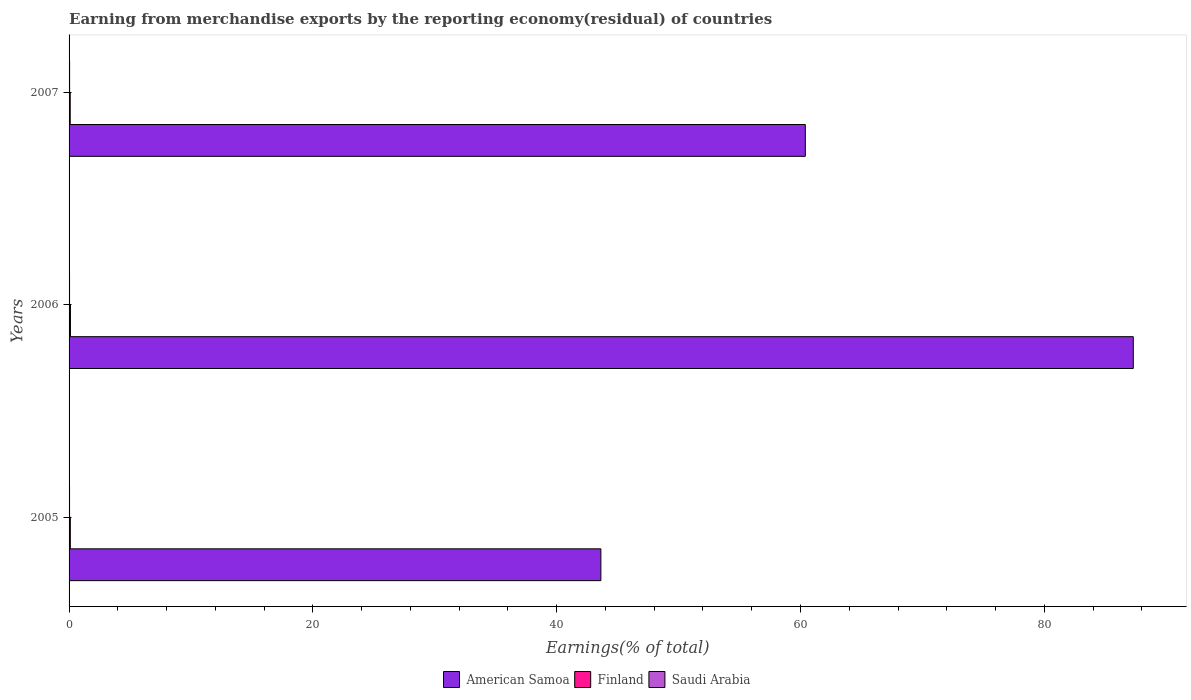Are the number of bars per tick equal to the number of legend labels?
Offer a terse response. Yes. Are the number of bars on each tick of the Y-axis equal?
Your response must be concise. Yes. How many bars are there on the 3rd tick from the top?
Your response must be concise. 3. How many bars are there on the 1st tick from the bottom?
Keep it short and to the point. 3. What is the label of the 3rd group of bars from the top?
Your answer should be compact. 2005. What is the percentage of amount earned from merchandise exports in Finland in 2007?
Make the answer very short. 0.09. Across all years, what is the maximum percentage of amount earned from merchandise exports in Saudi Arabia?
Offer a very short reply. 0.04. Across all years, what is the minimum percentage of amount earned from merchandise exports in Saudi Arabia?
Keep it short and to the point. 0.04. In which year was the percentage of amount earned from merchandise exports in American Samoa minimum?
Keep it short and to the point. 2005. What is the total percentage of amount earned from merchandise exports in American Samoa in the graph?
Keep it short and to the point. 191.32. What is the difference between the percentage of amount earned from merchandise exports in Saudi Arabia in 2005 and that in 2007?
Provide a succinct answer. -0. What is the difference between the percentage of amount earned from merchandise exports in American Samoa in 2005 and the percentage of amount earned from merchandise exports in Saudi Arabia in 2007?
Make the answer very short. 43.58. What is the average percentage of amount earned from merchandise exports in American Samoa per year?
Offer a very short reply. 63.77. In the year 2006, what is the difference between the percentage of amount earned from merchandise exports in American Samoa and percentage of amount earned from merchandise exports in Saudi Arabia?
Keep it short and to the point. 87.26. In how many years, is the percentage of amount earned from merchandise exports in Finland greater than 84 %?
Offer a terse response. 0. What is the ratio of the percentage of amount earned from merchandise exports in American Samoa in 2005 to that in 2007?
Offer a terse response. 0.72. Is the percentage of amount earned from merchandise exports in American Samoa in 2005 less than that in 2006?
Ensure brevity in your answer.  Yes. What is the difference between the highest and the second highest percentage of amount earned from merchandise exports in Finland?
Give a very brief answer. 0.01. What is the difference between the highest and the lowest percentage of amount earned from merchandise exports in American Samoa?
Offer a very short reply. 43.67. Is the sum of the percentage of amount earned from merchandise exports in Saudi Arabia in 2005 and 2007 greater than the maximum percentage of amount earned from merchandise exports in American Samoa across all years?
Give a very brief answer. No. What does the 3rd bar from the top in 2005 represents?
Offer a terse response. American Samoa. What does the 1st bar from the bottom in 2007 represents?
Make the answer very short. American Samoa. Is it the case that in every year, the sum of the percentage of amount earned from merchandise exports in Saudi Arabia and percentage of amount earned from merchandise exports in American Samoa is greater than the percentage of amount earned from merchandise exports in Finland?
Make the answer very short. Yes. Are the values on the major ticks of X-axis written in scientific E-notation?
Ensure brevity in your answer.  No. Does the graph contain grids?
Offer a terse response. No. Where does the legend appear in the graph?
Your answer should be very brief. Bottom center. How are the legend labels stacked?
Give a very brief answer. Horizontal. What is the title of the graph?
Your answer should be very brief. Earning from merchandise exports by the reporting economy(residual) of countries. Does "Uganda" appear as one of the legend labels in the graph?
Provide a short and direct response. No. What is the label or title of the X-axis?
Make the answer very short. Earnings(% of total). What is the Earnings(% of total) in American Samoa in 2005?
Your answer should be compact. 43.62. What is the Earnings(% of total) of Finland in 2005?
Ensure brevity in your answer.  0.1. What is the Earnings(% of total) in Saudi Arabia in 2005?
Give a very brief answer. 0.04. What is the Earnings(% of total) in American Samoa in 2006?
Provide a succinct answer. 87.3. What is the Earnings(% of total) of Finland in 2006?
Keep it short and to the point. 0.11. What is the Earnings(% of total) in Saudi Arabia in 2006?
Provide a succinct answer. 0.04. What is the Earnings(% of total) of American Samoa in 2007?
Ensure brevity in your answer.  60.4. What is the Earnings(% of total) of Finland in 2007?
Your answer should be compact. 0.09. What is the Earnings(% of total) in Saudi Arabia in 2007?
Your answer should be very brief. 0.04. Across all years, what is the maximum Earnings(% of total) of American Samoa?
Make the answer very short. 87.3. Across all years, what is the maximum Earnings(% of total) of Finland?
Keep it short and to the point. 0.11. Across all years, what is the maximum Earnings(% of total) of Saudi Arabia?
Offer a terse response. 0.04. Across all years, what is the minimum Earnings(% of total) in American Samoa?
Give a very brief answer. 43.62. Across all years, what is the minimum Earnings(% of total) of Finland?
Offer a very short reply. 0.09. Across all years, what is the minimum Earnings(% of total) in Saudi Arabia?
Your response must be concise. 0.04. What is the total Earnings(% of total) in American Samoa in the graph?
Provide a short and direct response. 191.32. What is the total Earnings(% of total) of Finland in the graph?
Provide a succinct answer. 0.31. What is the total Earnings(% of total) in Saudi Arabia in the graph?
Provide a short and direct response. 0.12. What is the difference between the Earnings(% of total) of American Samoa in 2005 and that in 2006?
Give a very brief answer. -43.67. What is the difference between the Earnings(% of total) in Finland in 2005 and that in 2006?
Offer a very short reply. -0.01. What is the difference between the Earnings(% of total) of Saudi Arabia in 2005 and that in 2006?
Offer a very short reply. 0. What is the difference between the Earnings(% of total) of American Samoa in 2005 and that in 2007?
Your answer should be very brief. -16.77. What is the difference between the Earnings(% of total) of Finland in 2005 and that in 2007?
Your response must be concise. 0.01. What is the difference between the Earnings(% of total) of Saudi Arabia in 2005 and that in 2007?
Your answer should be very brief. -0. What is the difference between the Earnings(% of total) in American Samoa in 2006 and that in 2007?
Keep it short and to the point. 26.9. What is the difference between the Earnings(% of total) of Finland in 2006 and that in 2007?
Give a very brief answer. 0.02. What is the difference between the Earnings(% of total) of Saudi Arabia in 2006 and that in 2007?
Offer a very short reply. -0.01. What is the difference between the Earnings(% of total) in American Samoa in 2005 and the Earnings(% of total) in Finland in 2006?
Your answer should be very brief. 43.51. What is the difference between the Earnings(% of total) of American Samoa in 2005 and the Earnings(% of total) of Saudi Arabia in 2006?
Provide a short and direct response. 43.59. What is the difference between the Earnings(% of total) in Finland in 2005 and the Earnings(% of total) in Saudi Arabia in 2006?
Offer a terse response. 0.06. What is the difference between the Earnings(% of total) in American Samoa in 2005 and the Earnings(% of total) in Finland in 2007?
Offer a very short reply. 43.53. What is the difference between the Earnings(% of total) in American Samoa in 2005 and the Earnings(% of total) in Saudi Arabia in 2007?
Provide a short and direct response. 43.58. What is the difference between the Earnings(% of total) in Finland in 2005 and the Earnings(% of total) in Saudi Arabia in 2007?
Your answer should be compact. 0.06. What is the difference between the Earnings(% of total) of American Samoa in 2006 and the Earnings(% of total) of Finland in 2007?
Your response must be concise. 87.2. What is the difference between the Earnings(% of total) in American Samoa in 2006 and the Earnings(% of total) in Saudi Arabia in 2007?
Make the answer very short. 87.26. What is the difference between the Earnings(% of total) in Finland in 2006 and the Earnings(% of total) in Saudi Arabia in 2007?
Keep it short and to the point. 0.07. What is the average Earnings(% of total) in American Samoa per year?
Make the answer very short. 63.77. What is the average Earnings(% of total) of Finland per year?
Provide a succinct answer. 0.1. What is the average Earnings(% of total) of Saudi Arabia per year?
Your response must be concise. 0.04. In the year 2005, what is the difference between the Earnings(% of total) in American Samoa and Earnings(% of total) in Finland?
Offer a terse response. 43.52. In the year 2005, what is the difference between the Earnings(% of total) in American Samoa and Earnings(% of total) in Saudi Arabia?
Offer a terse response. 43.58. In the year 2005, what is the difference between the Earnings(% of total) in Finland and Earnings(% of total) in Saudi Arabia?
Make the answer very short. 0.06. In the year 2006, what is the difference between the Earnings(% of total) of American Samoa and Earnings(% of total) of Finland?
Ensure brevity in your answer.  87.19. In the year 2006, what is the difference between the Earnings(% of total) in American Samoa and Earnings(% of total) in Saudi Arabia?
Give a very brief answer. 87.26. In the year 2006, what is the difference between the Earnings(% of total) in Finland and Earnings(% of total) in Saudi Arabia?
Ensure brevity in your answer.  0.07. In the year 2007, what is the difference between the Earnings(% of total) in American Samoa and Earnings(% of total) in Finland?
Offer a very short reply. 60.3. In the year 2007, what is the difference between the Earnings(% of total) in American Samoa and Earnings(% of total) in Saudi Arabia?
Make the answer very short. 60.35. In the year 2007, what is the difference between the Earnings(% of total) of Finland and Earnings(% of total) of Saudi Arabia?
Your answer should be very brief. 0.05. What is the ratio of the Earnings(% of total) in American Samoa in 2005 to that in 2006?
Your response must be concise. 0.5. What is the ratio of the Earnings(% of total) of Finland in 2005 to that in 2006?
Your answer should be compact. 0.92. What is the ratio of the Earnings(% of total) in Saudi Arabia in 2005 to that in 2006?
Offer a very short reply. 1.02. What is the ratio of the Earnings(% of total) in American Samoa in 2005 to that in 2007?
Offer a very short reply. 0.72. What is the ratio of the Earnings(% of total) in Finland in 2005 to that in 2007?
Ensure brevity in your answer.  1.09. What is the ratio of the Earnings(% of total) of Saudi Arabia in 2005 to that in 2007?
Provide a short and direct response. 0.91. What is the ratio of the Earnings(% of total) in American Samoa in 2006 to that in 2007?
Your answer should be compact. 1.45. What is the ratio of the Earnings(% of total) of Finland in 2006 to that in 2007?
Offer a terse response. 1.18. What is the ratio of the Earnings(% of total) in Saudi Arabia in 2006 to that in 2007?
Your response must be concise. 0.89. What is the difference between the highest and the second highest Earnings(% of total) of American Samoa?
Keep it short and to the point. 26.9. What is the difference between the highest and the second highest Earnings(% of total) of Finland?
Keep it short and to the point. 0.01. What is the difference between the highest and the second highest Earnings(% of total) of Saudi Arabia?
Your answer should be compact. 0. What is the difference between the highest and the lowest Earnings(% of total) in American Samoa?
Provide a succinct answer. 43.67. What is the difference between the highest and the lowest Earnings(% of total) in Finland?
Offer a terse response. 0.02. What is the difference between the highest and the lowest Earnings(% of total) of Saudi Arabia?
Offer a terse response. 0.01. 